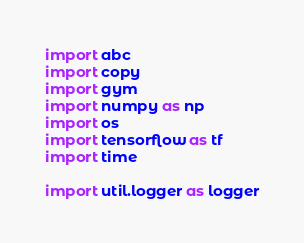<code> <loc_0><loc_0><loc_500><loc_500><_Python_>import abc
import copy
import gym
import numpy as np
import os
import tensorflow as tf
import time

import util.logger as logger</code> 